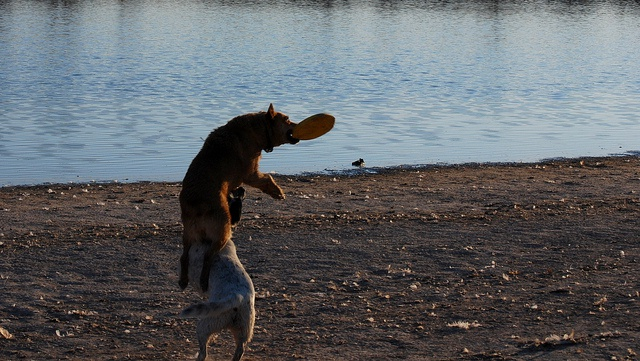Describe the objects in this image and their specific colors. I can see dog in black, maroon, darkgray, and gray tones, dog in black, gray, and tan tones, and frisbee in black, maroon, and gray tones in this image. 